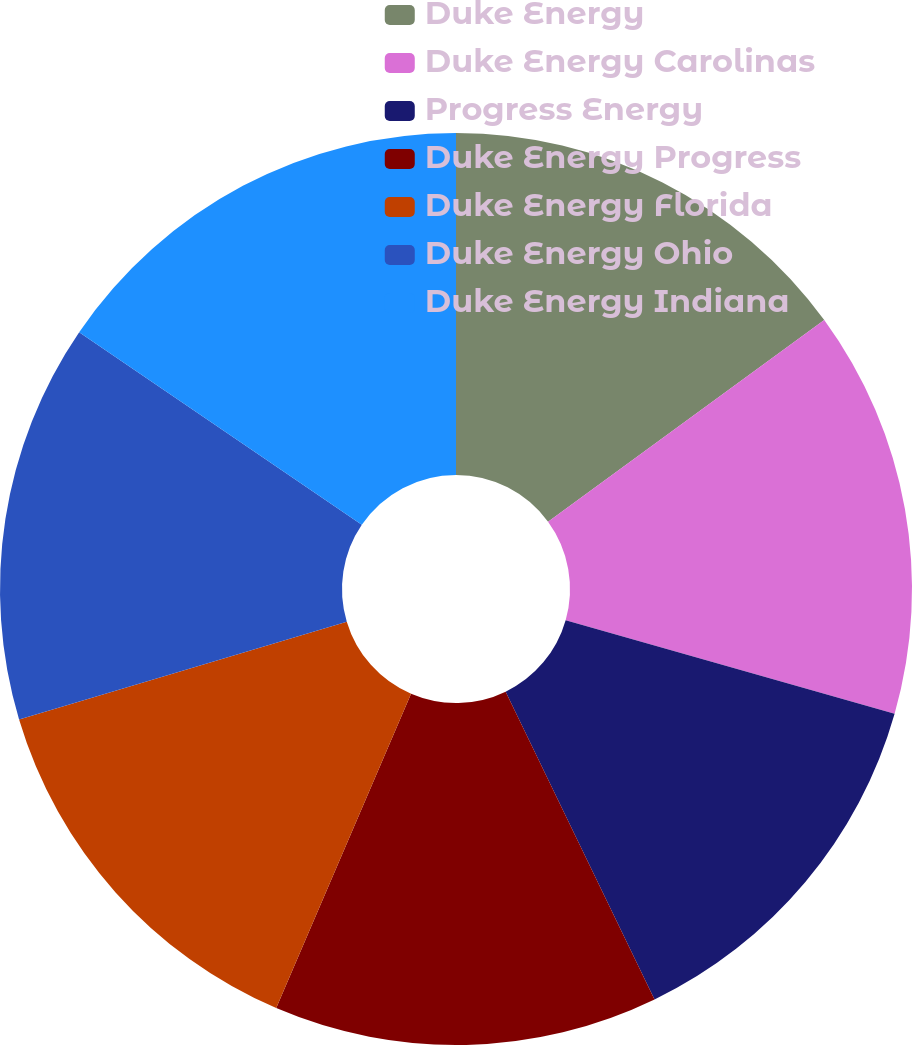Convert chart. <chart><loc_0><loc_0><loc_500><loc_500><pie_chart><fcel>Duke Energy<fcel>Duke Energy Carolinas<fcel>Progress Energy<fcel>Duke Energy Progress<fcel>Duke Energy Florida<fcel>Duke Energy Ohio<fcel>Duke Energy Indiana<nl><fcel>14.96%<fcel>14.45%<fcel>13.42%<fcel>13.62%<fcel>13.93%<fcel>14.14%<fcel>15.48%<nl></chart> 